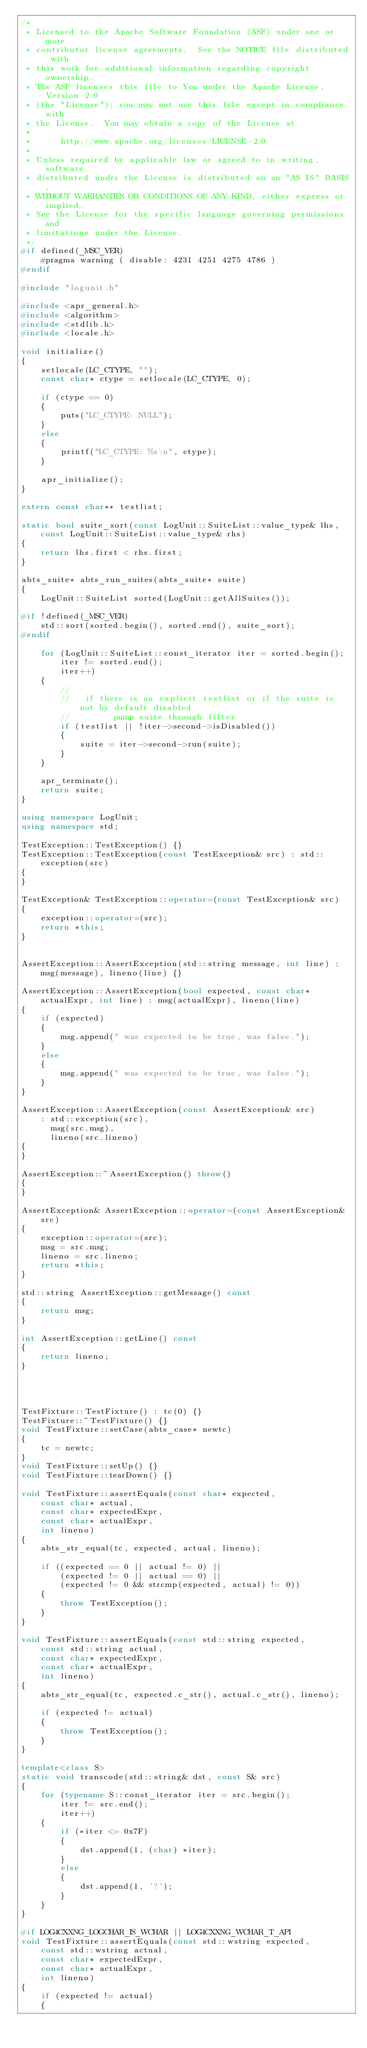Convert code to text. <code><loc_0><loc_0><loc_500><loc_500><_C++_>/*
 * Licensed to the Apache Software Foundation (ASF) under one or more
 * contributor license agreements.  See the NOTICE file distributed with
 * this work for additional information regarding copyright ownership.
 * The ASF licenses this file to You under the Apache License, Version 2.0
 * (the "License"); you may not use this file except in compliance with
 * the License.  You may obtain a copy of the License at
 *
 *      http://www.apache.org/licenses/LICENSE-2.0
 *
 * Unless required by applicable law or agreed to in writing, software
 * distributed under the License is distributed on an "AS IS" BASIS,
 * WITHOUT WARRANTIES OR CONDITIONS OF ANY KIND, either express or implied.
 * See the License for the specific language governing permissions and
 * limitations under the License.
 */
#if defined(_MSC_VER)
	#pragma warning ( disable: 4231 4251 4275 4786 )
#endif

#include "logunit.h"

#include <apr_general.h>
#include <algorithm>
#include <stdlib.h>
#include <locale.h>

void initialize()
{
	setlocale(LC_CTYPE, "");
	const char* ctype = setlocale(LC_CTYPE, 0);

	if (ctype == 0)
	{
		puts("LC_CTYPE: NULL");
	}
	else
	{
		printf("LC_CTYPE: %s\n", ctype);
	}

	apr_initialize();
}

extern const char** testlist;

static bool suite_sort(const LogUnit::SuiteList::value_type& lhs, const LogUnit::SuiteList::value_type& rhs)
{
	return lhs.first < rhs.first;
}

abts_suite* abts_run_suites(abts_suite* suite)
{
	LogUnit::SuiteList sorted(LogUnit::getAllSuites());

#if !defined(_MSC_VER)
	std::sort(sorted.begin(), sorted.end(), suite_sort);
#endif

	for (LogUnit::SuiteList::const_iterator iter = sorted.begin();
		iter != sorted.end();
		iter++)
	{
		//
		//   if there is an explicit testlist or if the suite is not by default disabled
		//         pump suite through filter
		if (testlist || !iter->second->isDisabled())
		{
			suite = iter->second->run(suite);
		}
	}

	apr_terminate();
	return suite;
}

using namespace LogUnit;
using namespace std;

TestException::TestException() {}
TestException::TestException(const TestException& src) : std::exception(src)
{
}

TestException& TestException::operator=(const TestException& src)
{
	exception::operator=(src);
	return *this;
}


AssertException::AssertException(std::string message, int line) : msg(message), lineno(line) {}

AssertException::AssertException(bool expected, const char* actualExpr, int line) : msg(actualExpr), lineno(line)
{
	if (expected)
	{
		msg.append(" was expected to be true, was false.");
	}
	else
	{
		msg.append(" was expected to be true, was false.");
	}
}

AssertException::AssertException(const AssertException& src)
	: std::exception(src),
	  msg(src.msg),
	  lineno(src.lineno)
{
}

AssertException::~AssertException() throw()
{
}

AssertException& AssertException::operator=(const AssertException& src)
{
	exception::operator=(src);
	msg = src.msg;
	lineno = src.lineno;
	return *this;
}

std::string AssertException::getMessage() const
{
	return msg;
}

int AssertException::getLine() const
{
	return lineno;
}




TestFixture::TestFixture() : tc(0) {}
TestFixture::~TestFixture() {}
void TestFixture::setCase(abts_case* newtc)
{
	tc = newtc;
}
void TestFixture::setUp() {}
void TestFixture::tearDown() {}

void TestFixture::assertEquals(const char* expected,
	const char* actual,
	const char* expectedExpr,
	const char* actualExpr,
	int lineno)
{
	abts_str_equal(tc, expected, actual, lineno);

	if ((expected == 0 || actual != 0) ||
		(expected != 0 || actual == 0) ||
		(expected != 0 && strcmp(expected, actual) != 0))
	{
		throw TestException();
	}
}

void TestFixture::assertEquals(const std::string expected,
	const std::string actual,
	const char* expectedExpr,
	const char* actualExpr,
	int lineno)
{
	abts_str_equal(tc, expected.c_str(), actual.c_str(), lineno);

	if (expected != actual)
	{
		throw TestException();
	}
}

template<class S>
static void transcode(std::string& dst, const S& src)
{
	for (typename S::const_iterator iter = src.begin();
		iter != src.end();
		iter++)
	{
		if (*iter <= 0x7F)
		{
			dst.append(1, (char) *iter);
		}
		else
		{
			dst.append(1, '?');
		}
	}
}

#if LOG4CXXNG_LOGCHAR_IS_WCHAR || LOG4CXXNG_WCHAR_T_API
void TestFixture::assertEquals(const std::wstring expected,
	const std::wstring actual,
	const char* expectedExpr,
	const char* actualExpr,
	int lineno)
{
	if (expected != actual)
	{</code> 